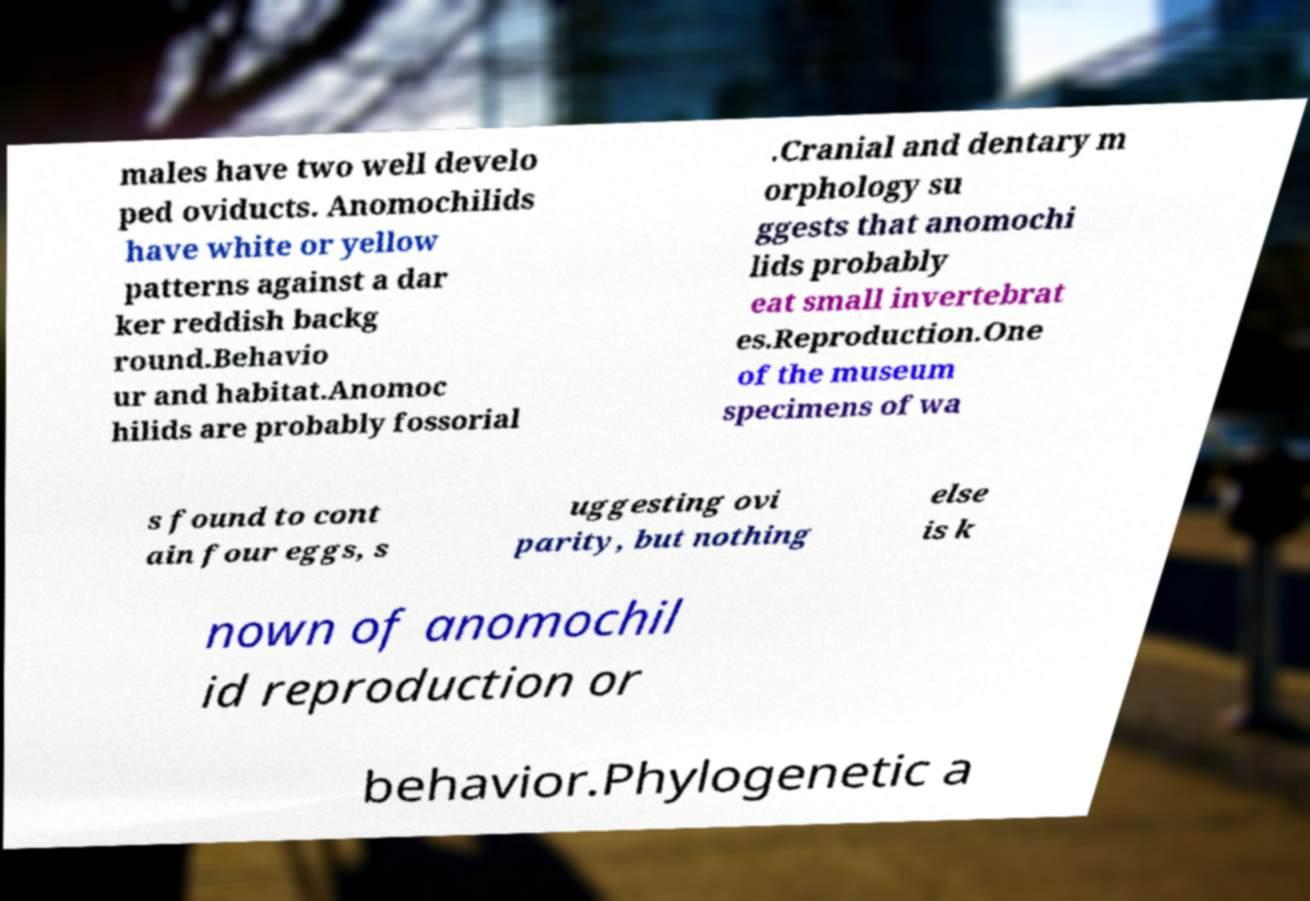Could you assist in decoding the text presented in this image and type it out clearly? males have two well develo ped oviducts. Anomochilids have white or yellow patterns against a dar ker reddish backg round.Behavio ur and habitat.Anomoc hilids are probably fossorial .Cranial and dentary m orphology su ggests that anomochi lids probably eat small invertebrat es.Reproduction.One of the museum specimens of wa s found to cont ain four eggs, s uggesting ovi parity, but nothing else is k nown of anomochil id reproduction or behavior.Phylogenetic a 